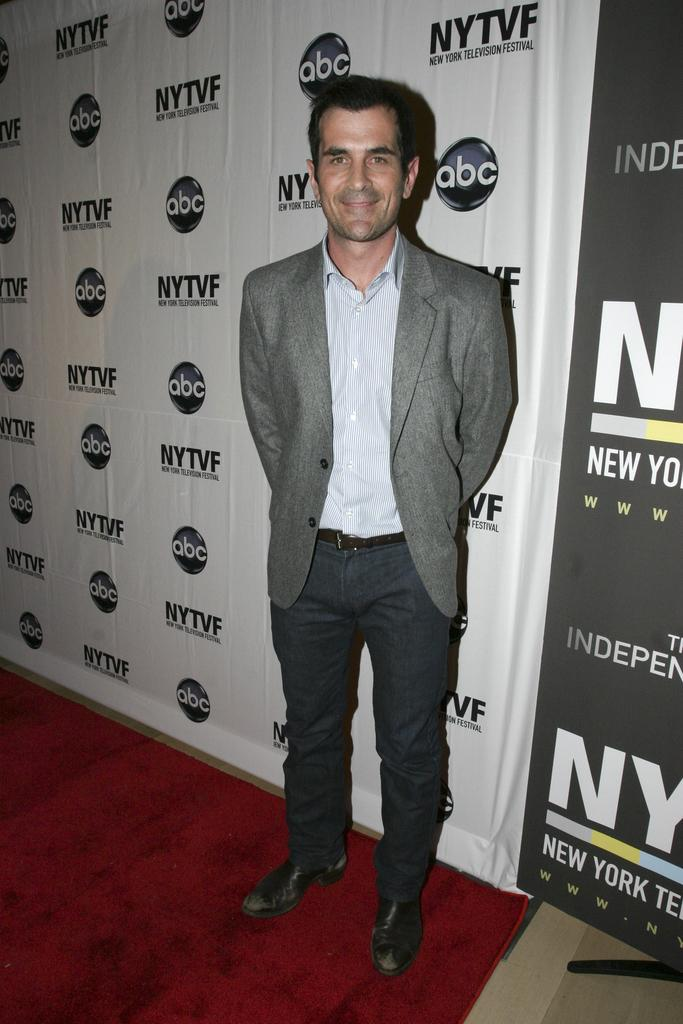What is the main subject of the image? The main subject of the image is a man. What is the man wearing in the image? The man is wearing a suit, a shirt, trousers, and shoes. What is the man's posture in the image? The man is standing in the image. What can be seen in the background of the image? There are posters and text visible in the background of the image. How many arches can be seen in the image? There are no arches present in the image. What type of planes can be seen flying in the background of the image? There are no planes visible in the image; only posters and text are present in the background. 